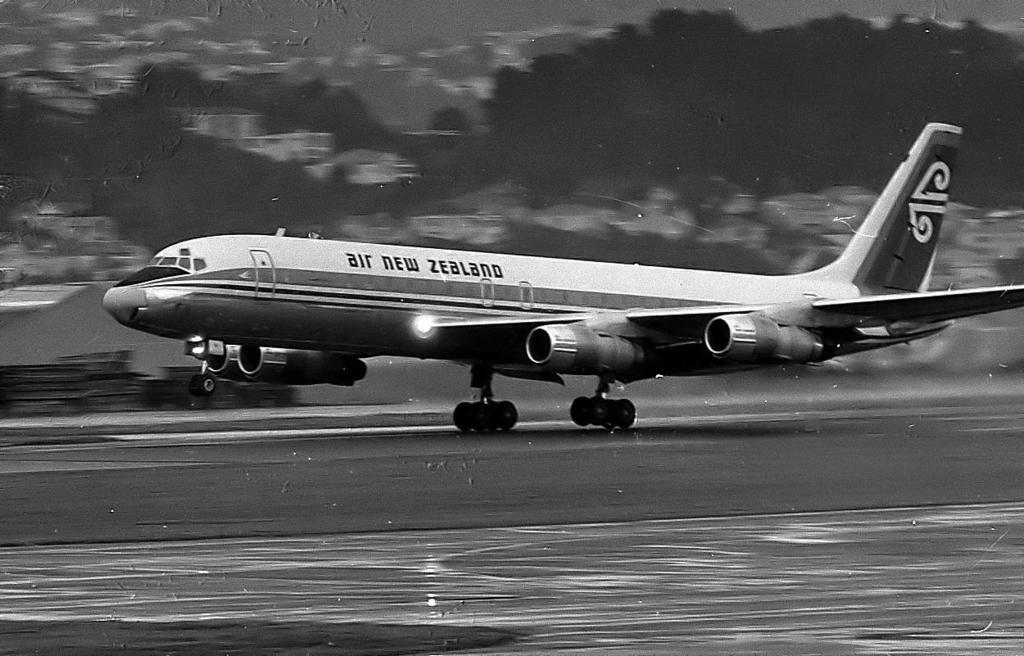Provide a one-sentence caption for the provided image. A black and white image of an Air New Zealand plane. 